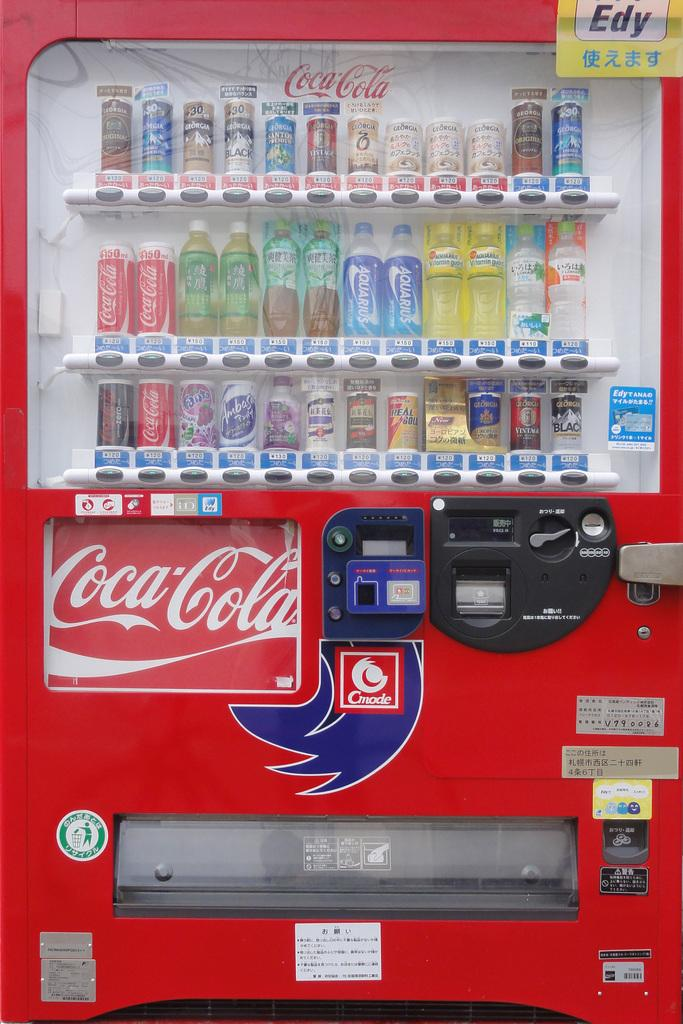Provide a one-sentence caption for the provided image. The Coca Cola branded vending machine also has other drinks including Fanta Grape, Georgia Black, and Aquarius. 